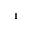<formula> <loc_0><loc_0><loc_500><loc_500>_ { 1 }</formula> 